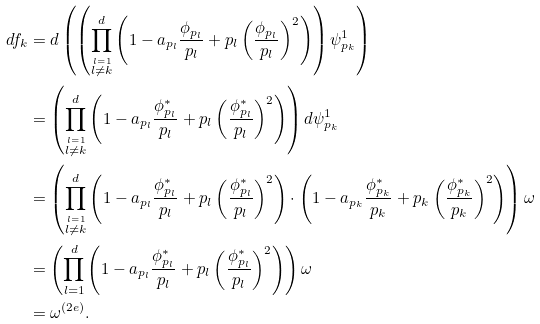Convert formula to latex. <formula><loc_0><loc_0><loc_500><loc_500>d f _ { k } & = d \left ( \left ( \prod _ { \stackrel { l = 1 } { l \neq k } } ^ { d } \left ( 1 - a _ { p _ { l } } \frac { \phi _ { p _ { l } } } { p _ { l } } + p _ { l } \left ( \frac { \phi _ { p _ { l } } } { p _ { l } } \right ) ^ { 2 } \right ) \right ) \psi ^ { 1 } _ { p _ { k } } \right ) \\ & = \left ( \prod _ { \stackrel { l = 1 } { l \neq k } } ^ { d } \left ( 1 - a _ { p _ { l } } \frac { \phi ^ { * } _ { p _ { l } } } { p _ { l } } + p _ { l } \left ( \frac { \phi ^ { * } _ { p _ { l } } } { p _ { l } } \right ) ^ { 2 } \right ) \right ) d \psi ^ { 1 } _ { p _ { k } } \\ & = \left ( \prod _ { \stackrel { l = 1 } { l \neq k } } ^ { d } \left ( 1 - a _ { p _ { l } } \frac { \phi ^ { * } _ { p _ { l } } } { p _ { l } } + p _ { l } \left ( \frac { \phi ^ { * } _ { p _ { l } } } { p _ { l } } \right ) ^ { 2 } \right ) \cdot \left ( 1 - a _ { p _ { k } } \frac { \phi ^ { * } _ { p _ { k } } } { p _ { k } } + p _ { k } \left ( \frac { \phi ^ { * } _ { p _ { k } } } { p _ { k } } \right ) ^ { 2 } \right ) \right ) \omega \\ & = \left ( \prod _ { l = 1 } ^ { d } \left ( 1 - a _ { p _ { l } } \frac { \phi ^ { * } _ { p _ { l } } } { p _ { l } } + p _ { l } \left ( \frac { \phi ^ { * } _ { p _ { l } } } { p _ { l } } \right ) ^ { 2 } \right ) \right ) \omega \\ & = \omega ^ { ( 2 e ) } .</formula> 